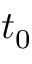<formula> <loc_0><loc_0><loc_500><loc_500>t _ { 0 }</formula> 